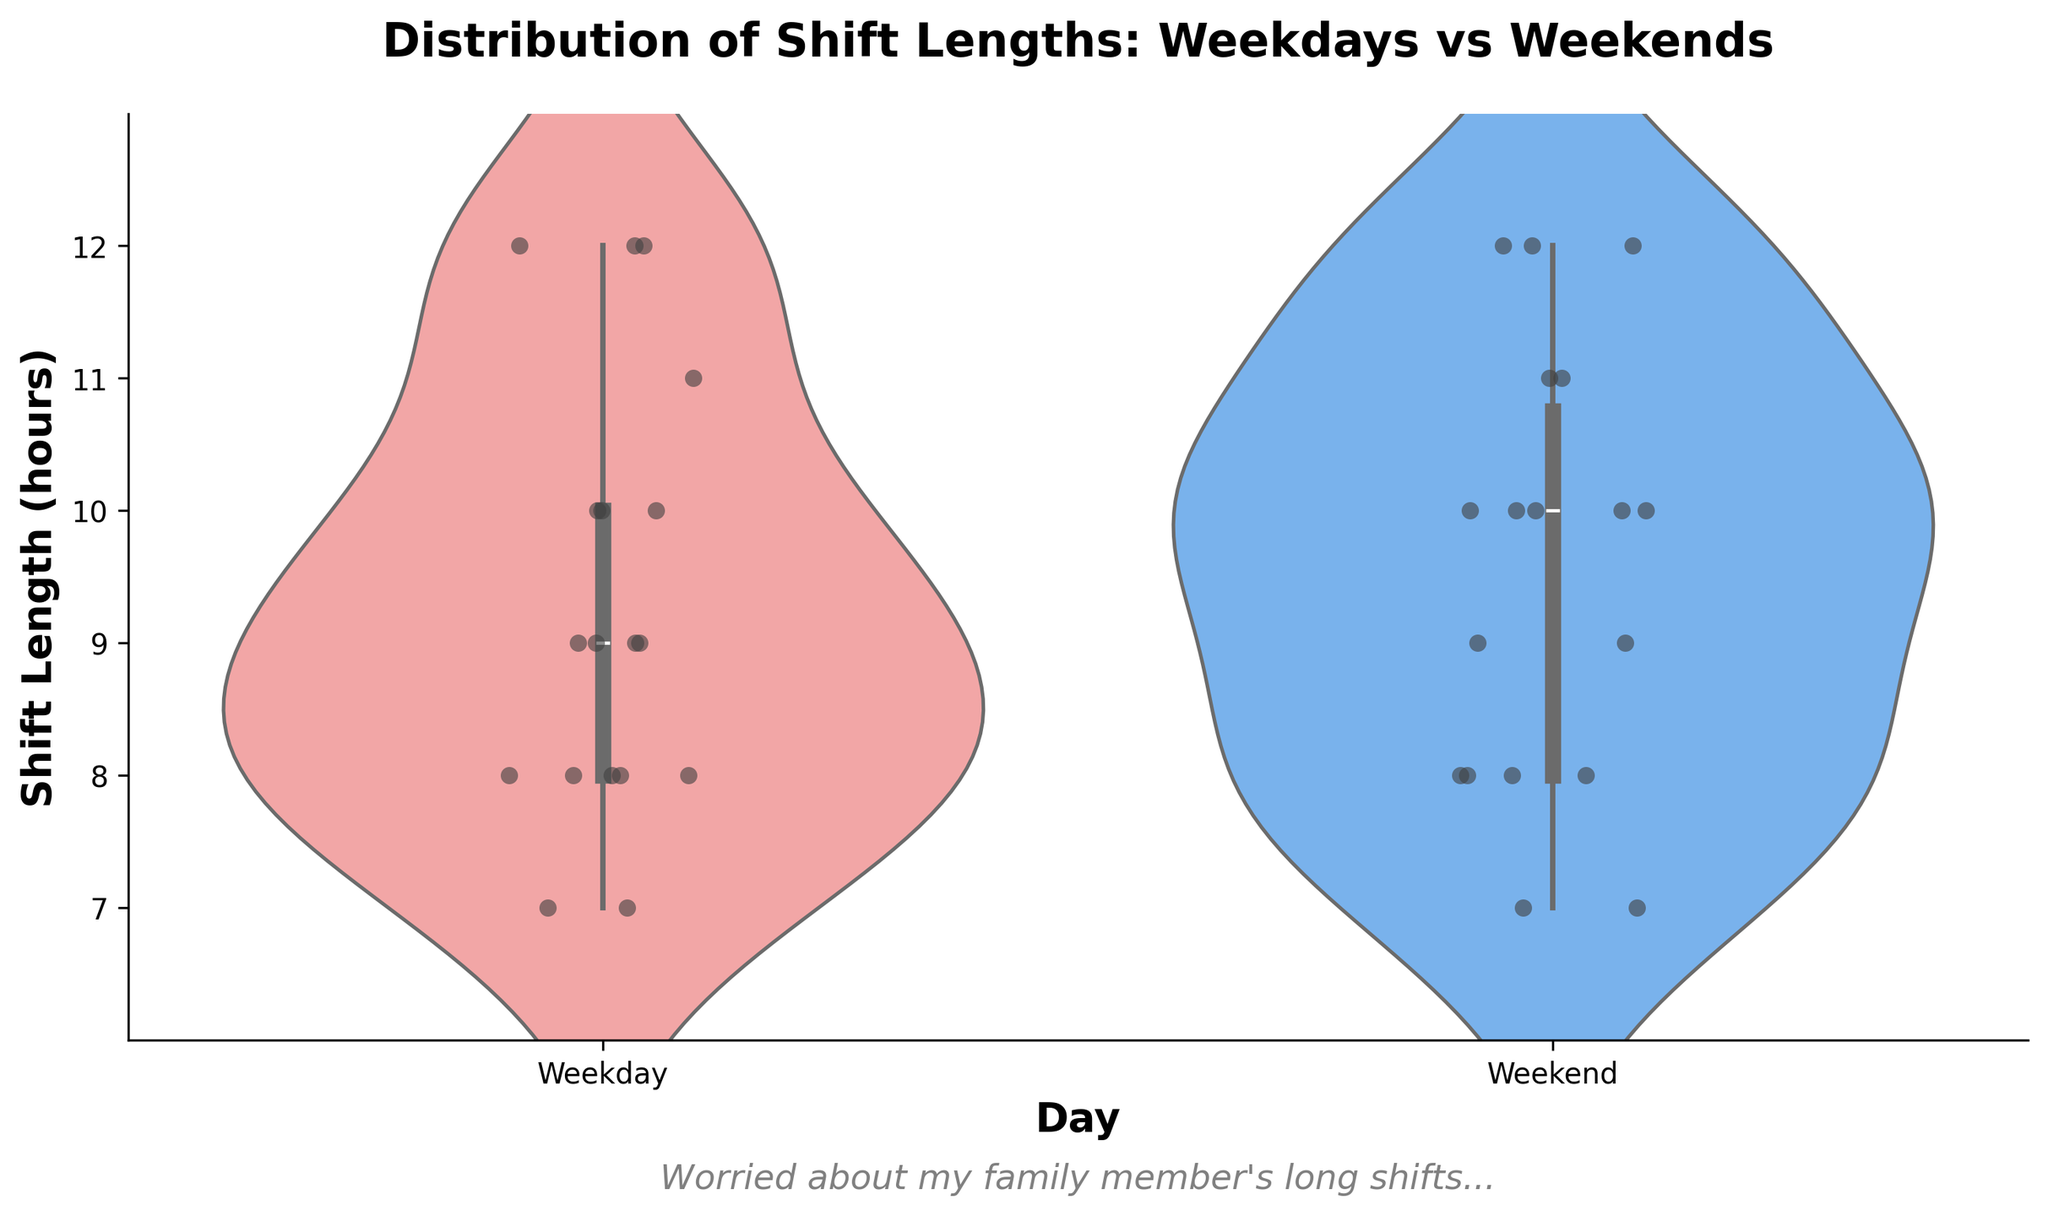What's the title of the figure? The title of the figure is written at the top of the plot, providing an overview of what the chart represents.
Answer: Distribution of Shift Lengths: Weekdays vs Weekends What are the x-axis labels? The x-axis labels represent the categories being compared in the Violin Chart, indicating over which periods the shifts are measured.
Answer: Weekday, Weekend Which color represents the weekday shifts in the chart? On the left-hand side of the Violin Chart, the color representing weekday shifts can be identified by the palette used.
Answer: Light red (pink) How many shift lengths were recorded for weekends? By counting the individual jittered points (dots) on the weekend violin plot, we can determine how many data points there are.
Answer: 18 Which day has the longest shift length visible on the plot? By observing the highest point on the y-axis within the violin plots, we can identify which day reaches the farthest vertically.
Answer: Both (12 hours for both) What is the median shift length on weekdays? The median shift length is indicated by the central line within the box part of the violin plot for weekdays. It can be seen at which y-axis value this central line is positioned.
Answer: 9 hours Do weekends generally have more variability in shift lengths compared to weekdays? By comparing the width and spread of the violin plots for weekdays and weekends, we can determine which plot shows a wider range of values indicating more variability.
Answer: No Which day has the higher concentration of shifts at 7 hours? The density and visual width around the 7-hour mark can show whether more shifts are concentrated at this length on weekdays or weekends.
Answer: Weekend Is the interquartile range (IQR) wider for weekdays or weekends? By observing the box within each violin plot, which represents the IQR, we can compare the vertical width of these boxes for weekdays and weekends.
Answer: Weekdays What does the italic text below the x-axis say? The text below the x-axis provides additional commentary related to the context of the data shown in the plot.
Answer: Worried about my family member's long shifts.. 